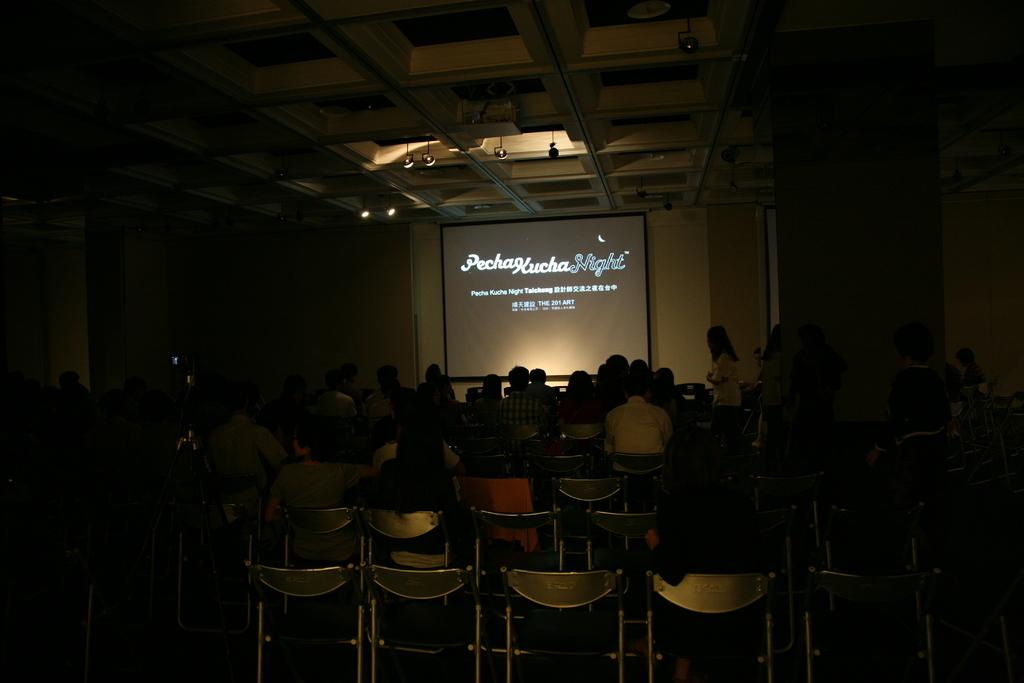What is happening in the image involving a group of people? There is a group of people in the image, and they are sitting on chairs. Can you describe the setting in which the people are sitting? The people are sitting on chairs in a setting where a projector is visible in the background. What type of hat is the person in the image wearing? There is no person wearing a hat in the image. How does the person in the image hear the presentation? The image does not show a person listening to a presentation, so it is not possible to determine how they hear it. 